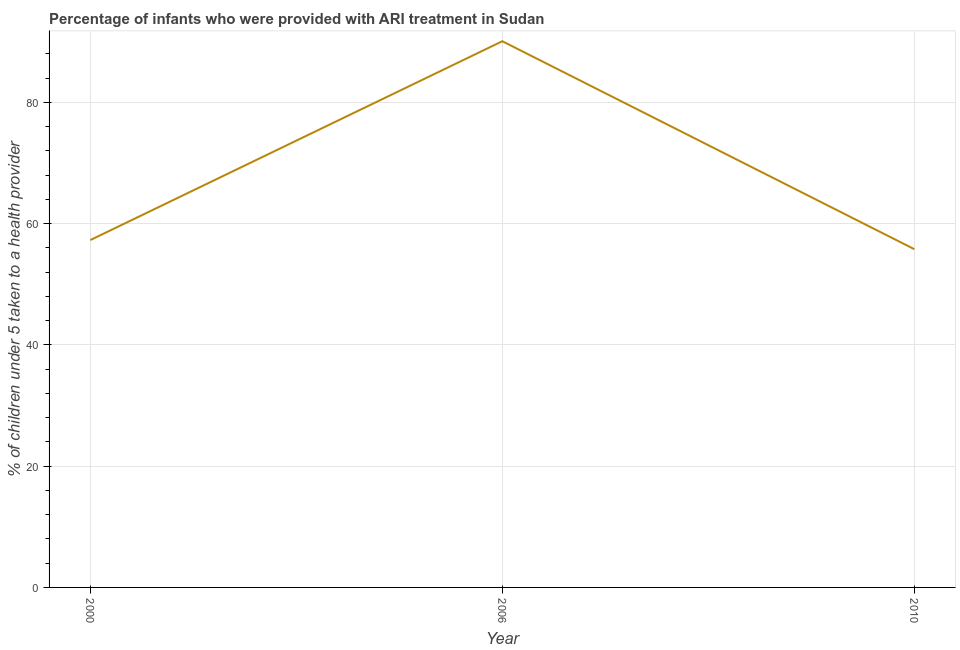What is the percentage of children who were provided with ari treatment in 2010?
Ensure brevity in your answer.  55.8. Across all years, what is the maximum percentage of children who were provided with ari treatment?
Keep it short and to the point. 90.1. Across all years, what is the minimum percentage of children who were provided with ari treatment?
Your answer should be compact. 55.8. In which year was the percentage of children who were provided with ari treatment maximum?
Provide a succinct answer. 2006. What is the sum of the percentage of children who were provided with ari treatment?
Provide a succinct answer. 203.2. What is the difference between the percentage of children who were provided with ari treatment in 2006 and 2010?
Give a very brief answer. 34.3. What is the average percentage of children who were provided with ari treatment per year?
Your answer should be very brief. 67.73. What is the median percentage of children who were provided with ari treatment?
Your answer should be compact. 57.3. In how many years, is the percentage of children who were provided with ari treatment greater than 32 %?
Your response must be concise. 3. What is the ratio of the percentage of children who were provided with ari treatment in 2006 to that in 2010?
Offer a very short reply. 1.61. Is the percentage of children who were provided with ari treatment in 2000 less than that in 2006?
Your answer should be compact. Yes. Is the difference between the percentage of children who were provided with ari treatment in 2006 and 2010 greater than the difference between any two years?
Your answer should be compact. Yes. What is the difference between the highest and the second highest percentage of children who were provided with ari treatment?
Give a very brief answer. 32.8. Is the sum of the percentage of children who were provided with ari treatment in 2000 and 2010 greater than the maximum percentage of children who were provided with ari treatment across all years?
Offer a very short reply. Yes. What is the difference between the highest and the lowest percentage of children who were provided with ari treatment?
Offer a very short reply. 34.3. Does the percentage of children who were provided with ari treatment monotonically increase over the years?
Provide a short and direct response. No. How many lines are there?
Provide a succinct answer. 1. How many years are there in the graph?
Your answer should be very brief. 3. What is the difference between two consecutive major ticks on the Y-axis?
Ensure brevity in your answer.  20. Are the values on the major ticks of Y-axis written in scientific E-notation?
Provide a succinct answer. No. Does the graph contain any zero values?
Provide a succinct answer. No. What is the title of the graph?
Provide a succinct answer. Percentage of infants who were provided with ARI treatment in Sudan. What is the label or title of the Y-axis?
Ensure brevity in your answer.  % of children under 5 taken to a health provider. What is the % of children under 5 taken to a health provider in 2000?
Make the answer very short. 57.3. What is the % of children under 5 taken to a health provider in 2006?
Make the answer very short. 90.1. What is the % of children under 5 taken to a health provider in 2010?
Give a very brief answer. 55.8. What is the difference between the % of children under 5 taken to a health provider in 2000 and 2006?
Provide a short and direct response. -32.8. What is the difference between the % of children under 5 taken to a health provider in 2006 and 2010?
Provide a short and direct response. 34.3. What is the ratio of the % of children under 5 taken to a health provider in 2000 to that in 2006?
Keep it short and to the point. 0.64. What is the ratio of the % of children under 5 taken to a health provider in 2006 to that in 2010?
Your response must be concise. 1.61. 